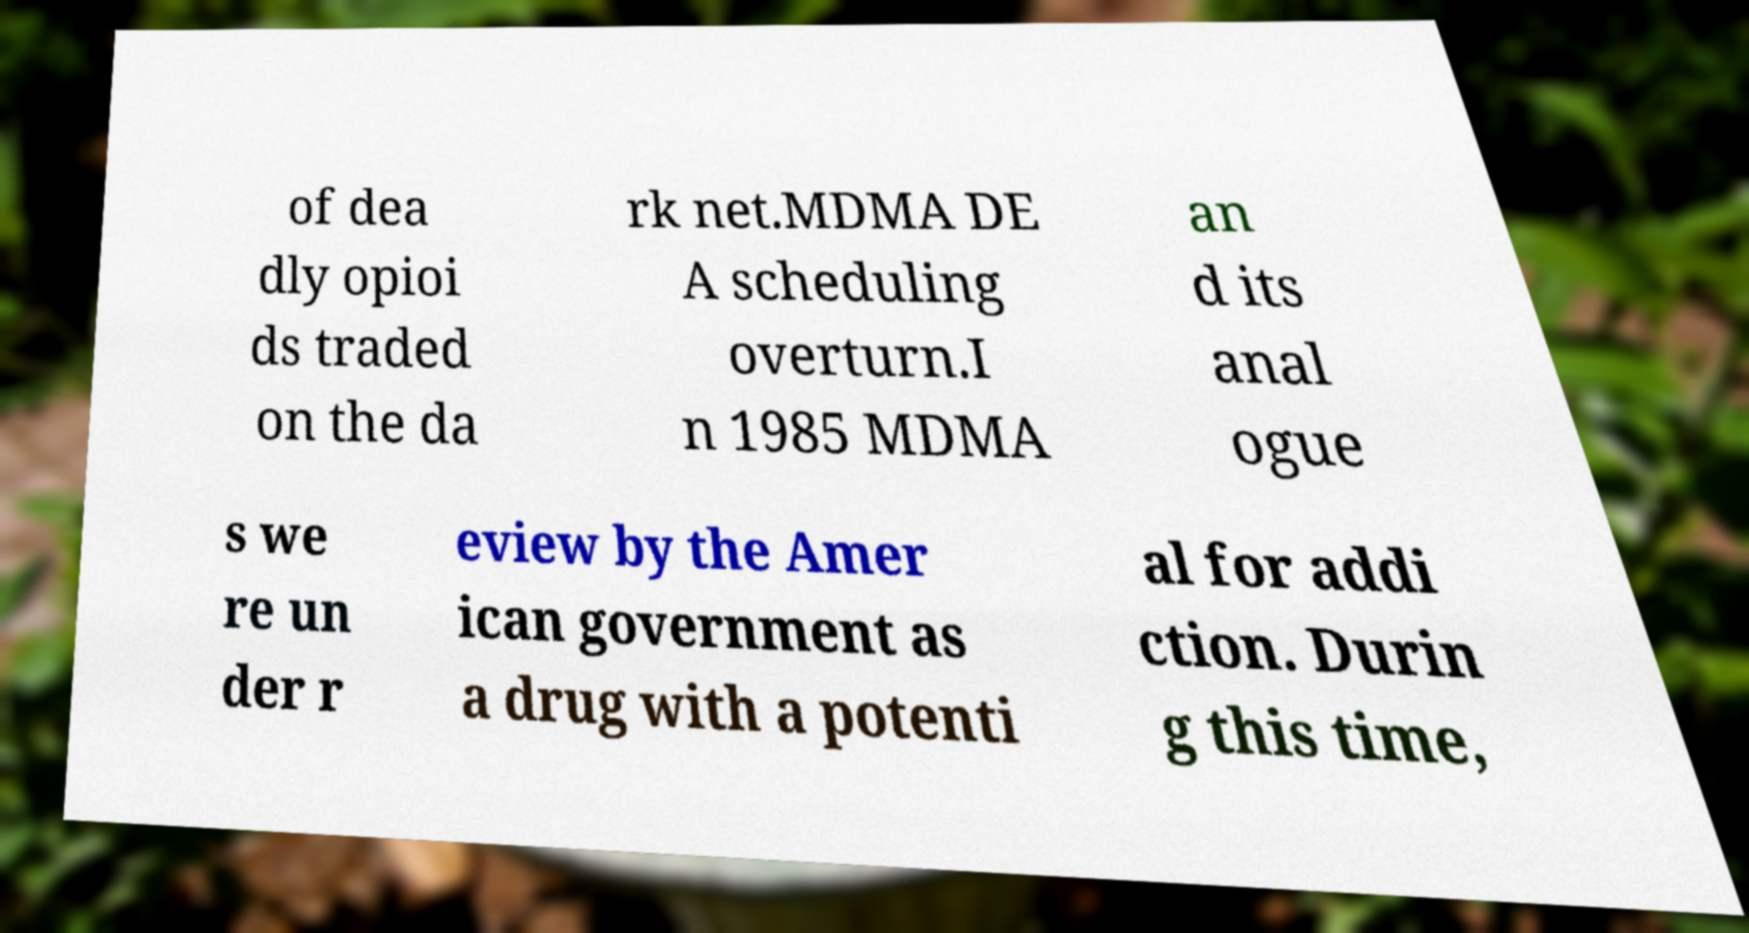Please identify and transcribe the text found in this image. of dea dly opioi ds traded on the da rk net.MDMA DE A scheduling overturn.I n 1985 MDMA an d its anal ogue s we re un der r eview by the Amer ican government as a drug with a potenti al for addi ction. Durin g this time, 